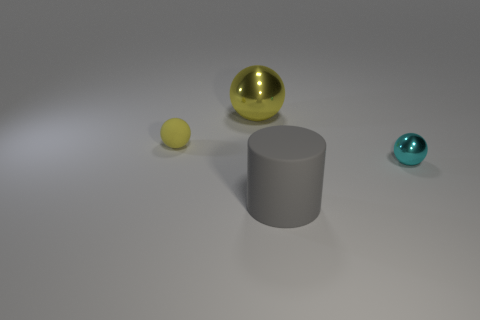Subtract all yellow balls. How many balls are left? 1 Subtract all cyan metallic spheres. How many spheres are left? 2 Subtract 0 red spheres. How many objects are left? 4 Subtract all cylinders. How many objects are left? 3 Subtract 1 balls. How many balls are left? 2 Subtract all brown cylinders. Subtract all cyan balls. How many cylinders are left? 1 Subtract all blue cylinders. How many cyan spheres are left? 1 Subtract all yellow matte balls. Subtract all metallic objects. How many objects are left? 1 Add 2 gray cylinders. How many gray cylinders are left? 3 Add 4 small cyan metal balls. How many small cyan metal balls exist? 5 